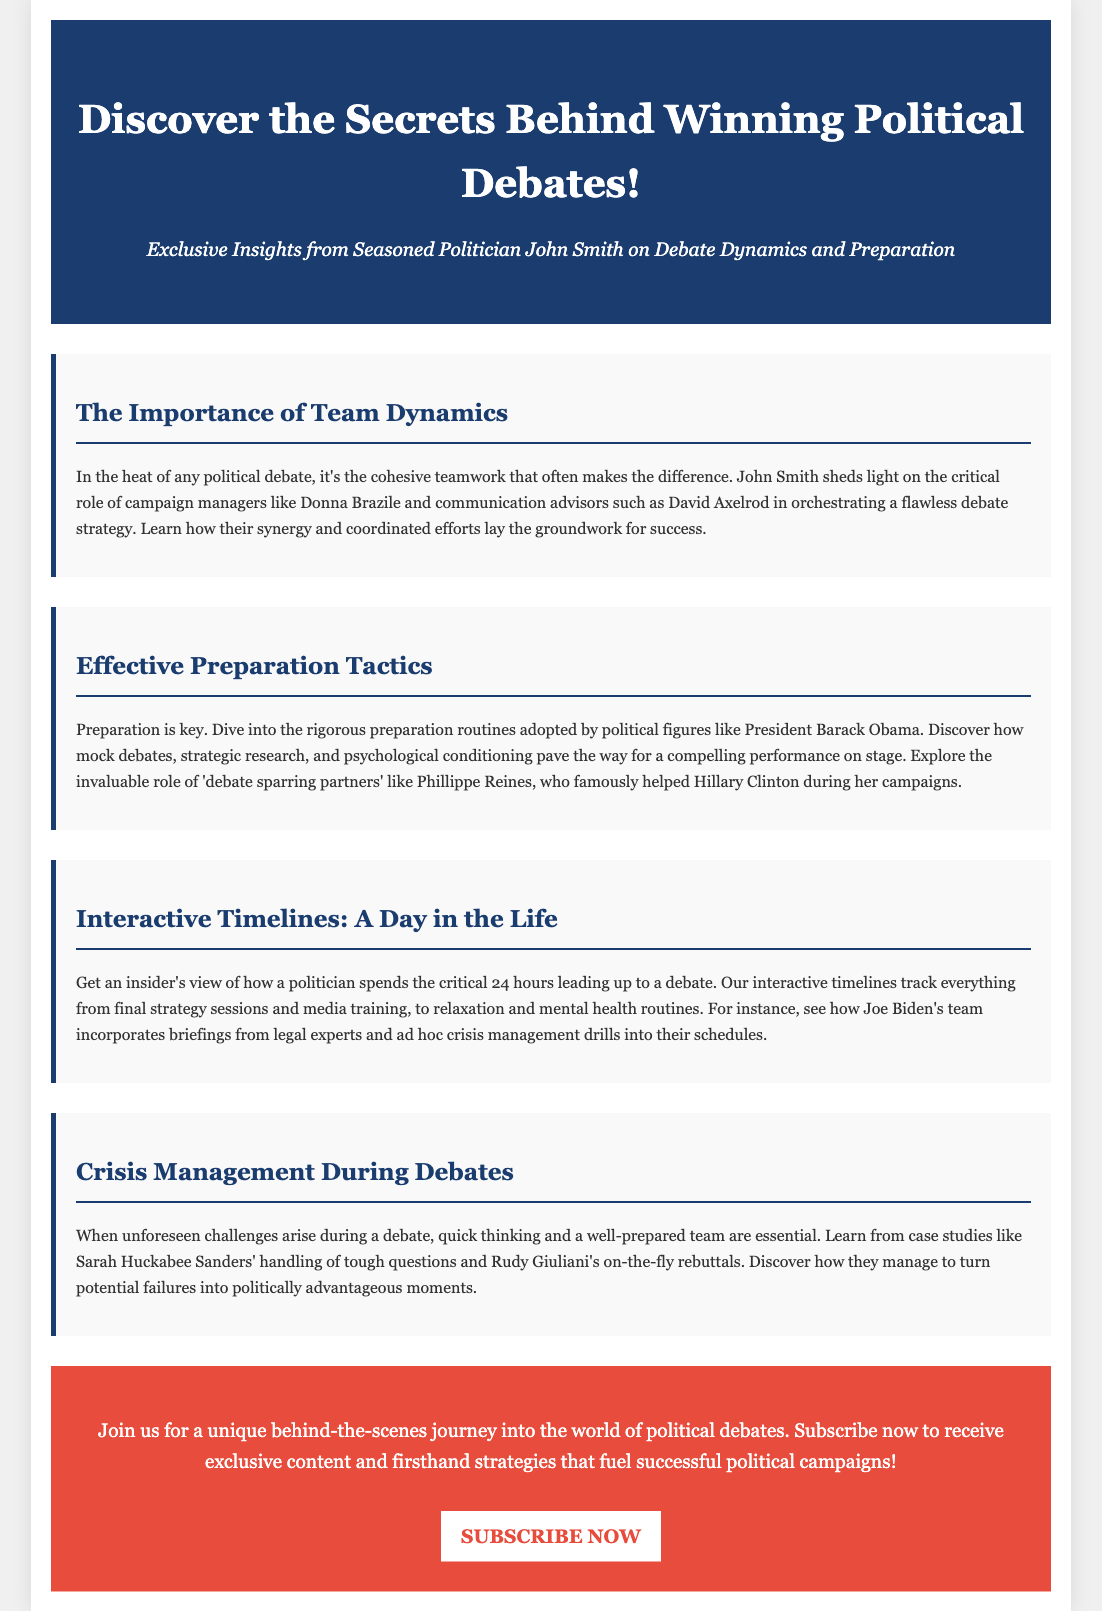What is the title of the advertisement? The title is prominently displayed at the top of the document, serving as the main heading for the content.
Answer: Discover the Secrets Behind Winning Political Debates! Who provides insights on debate dynamics? The advertisement mentions a seasoned politician known for his insights into debate dynamics.
Answer: John Smith Which campaign manager is highlighted in relation to team dynamics? A specific campaign manager is mentioned as critical to orchestrating debate strategy.
Answer: Donna Brazile What preparation routine is adopted by President Barack Obama? The advertisement discusses a specific tactic employed by Obama in preparation for debates.
Answer: Mock debates What does the interactive timeline illustrate? The timeline provides a structured overview of the activities leading up to a debate.
Answer: A Day in the Life Which figure is noted for helping Hillary Clinton during her campaigns? The document refers to an individual who served as a 'debate sparring partner' for Clinton.
Answer: Phillippe Reines What essential skill is emphasized for managing unforeseen challenges? The text highlights the importance of a specific type of thinking during debate crises.
Answer: Quick thinking What is the call to action in the advertisement? The advertisement concludes with a request for readers to engage with exclusive content.
Answer: Subscribe now 